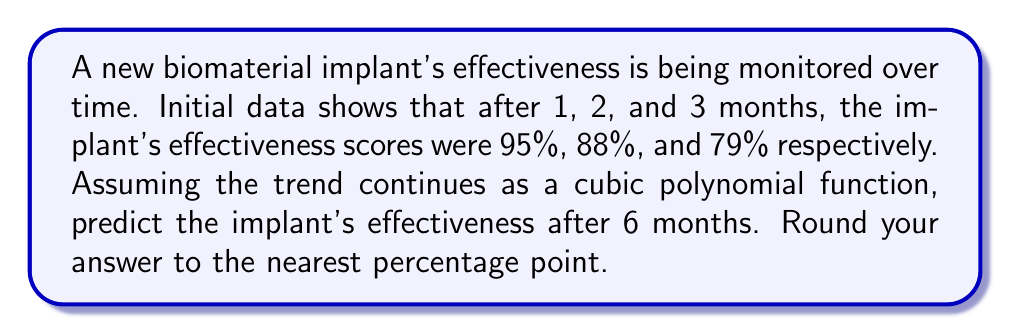Can you solve this math problem? Let's approach this step-by-step:

1) We need to find a cubic polynomial function in the form:
   $$f(x) = ax^3 + bx^2 + cx + d$$
   where $x$ is the number of months and $f(x)$ is the effectiveness percentage.

2) We have three data points:
   $f(1) = 95$
   $f(2) = 88$
   $f(3) = 79$

3) We also know that when $x = 0$ (at implantation), the effectiveness should be 100%:
   $f(0) = 100$

4) Now we can set up a system of equations:
   $$a(0)^3 + b(0)^2 + c(0) + d = 100$$
   $$a(1)^3 + b(1)^2 + c(1) + d = 95$$
   $$a(2)^3 + b(2)^2 + c(2) + d = 88$$
   $$a(3)^3 + b(3)^2 + c(3) + d = 79$$

5) Simplifying:
   $$d = 100$$
   $$a + b + c + 100 = 95$$
   $$8a + 4b + 2c + 100 = 88$$
   $$27a + 9b + 3c + 100 = 79$$

6) Solving this system of equations (you can use a calculator or computer algebra system), we get:
   $$a = -1$$
   $$b = 3$$
   $$c = -7$$
   $$d = 100$$

7) Therefore, our function is:
   $$f(x) = -x^3 + 3x^2 - 7x + 100$$

8) To predict the effectiveness after 6 months, we calculate $f(6)$:
   $$f(6) = -(6)^3 + 3(6)^2 - 7(6) + 100$$
   $$= -216 + 108 - 42 + 100$$
   $$= -50$$

9) Since effectiveness can't be negative, we'll assume it reaches 0% and stays there.
Answer: 0% 